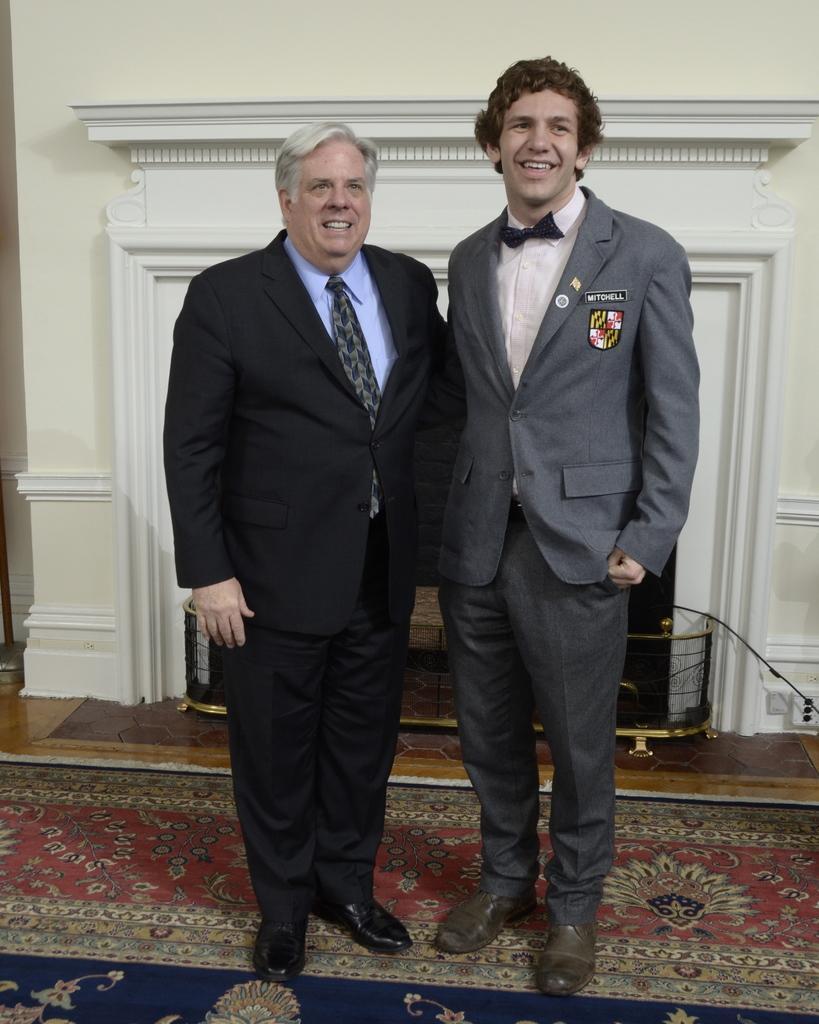In one or two sentences, can you explain what this image depicts? In this image, we can see two men standing on the carpet and smiling. In the background, there is a wall, grille, few objects and floor. 